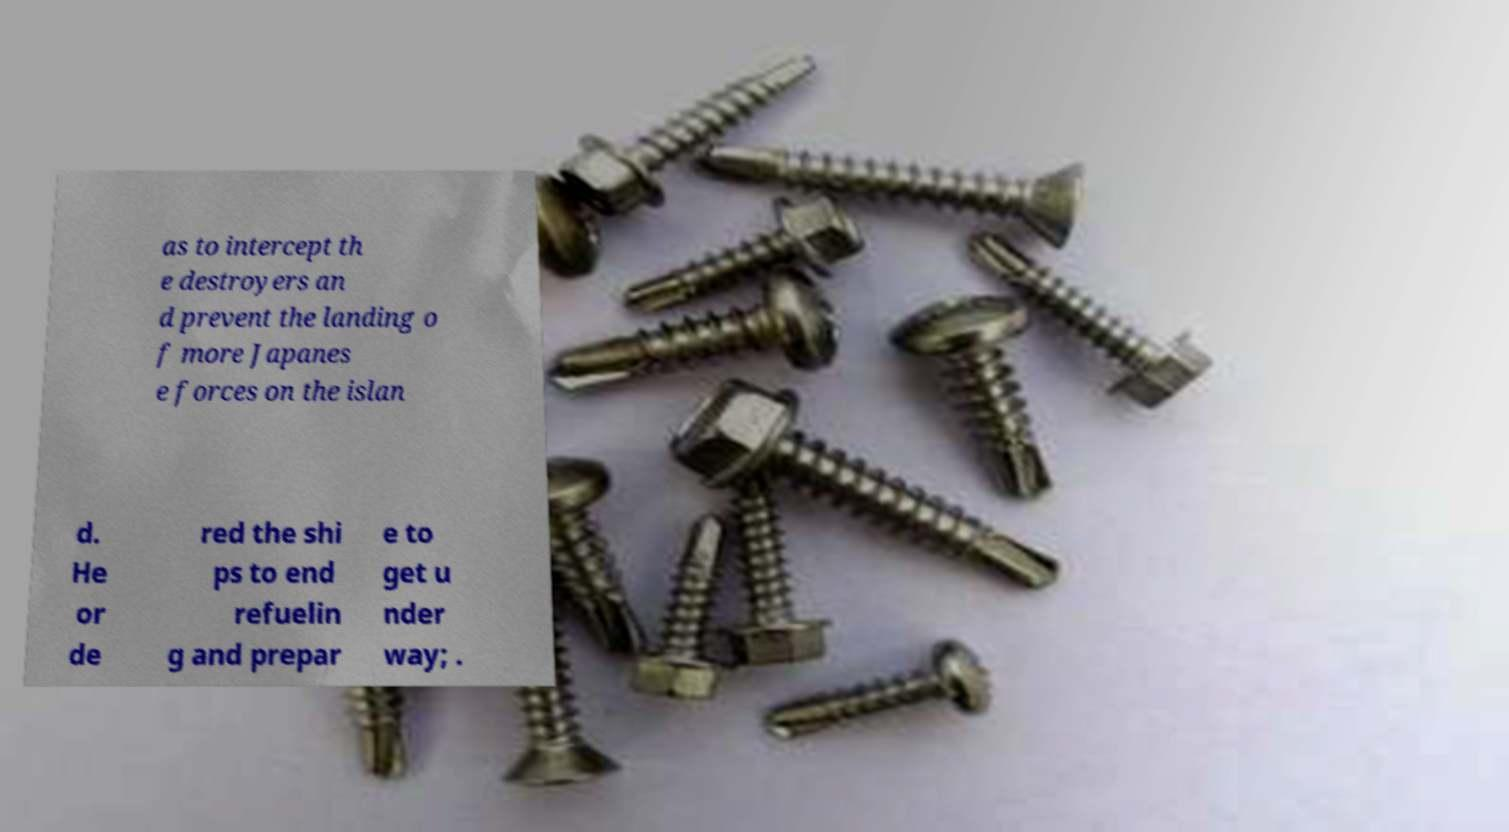There's text embedded in this image that I need extracted. Can you transcribe it verbatim? as to intercept th e destroyers an d prevent the landing o f more Japanes e forces on the islan d. He or de red the shi ps to end refuelin g and prepar e to get u nder way; . 